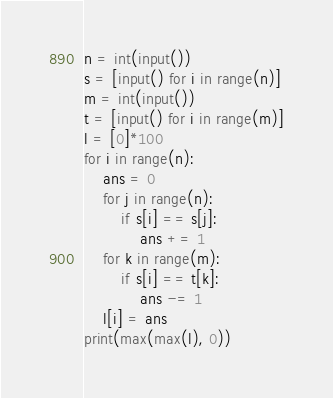<code> <loc_0><loc_0><loc_500><loc_500><_Python_>n = int(input())
s = [input() for i in range(n)]
m = int(input())
t = [input() for i in range(m)]
l = [0]*100
for i in range(n):
    ans = 0
    for j in range(n):
        if s[i] == s[j]:
            ans += 1
    for k in range(m):
        if s[i] == t[k]:
            ans -= 1
    l[i] = ans
print(max(max(l), 0))</code> 